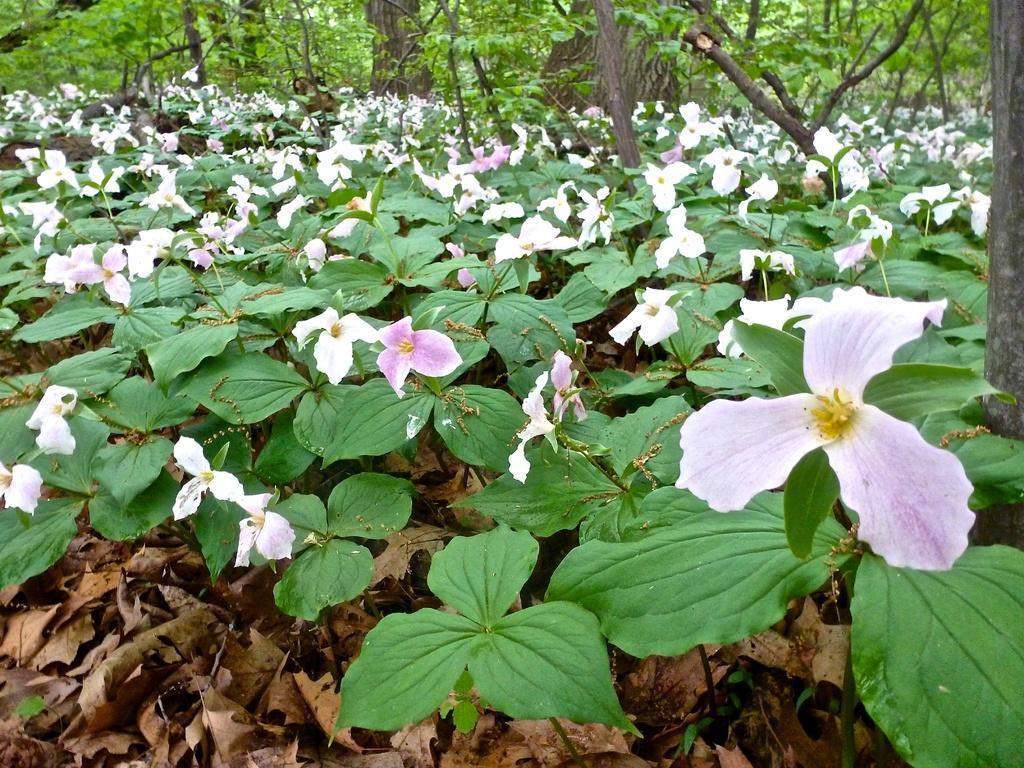In one or two sentences, can you explain what this image depicts? In this picture we can see plants with flowers on the ground, here we can see dried leaves and in the background we can see trees. 